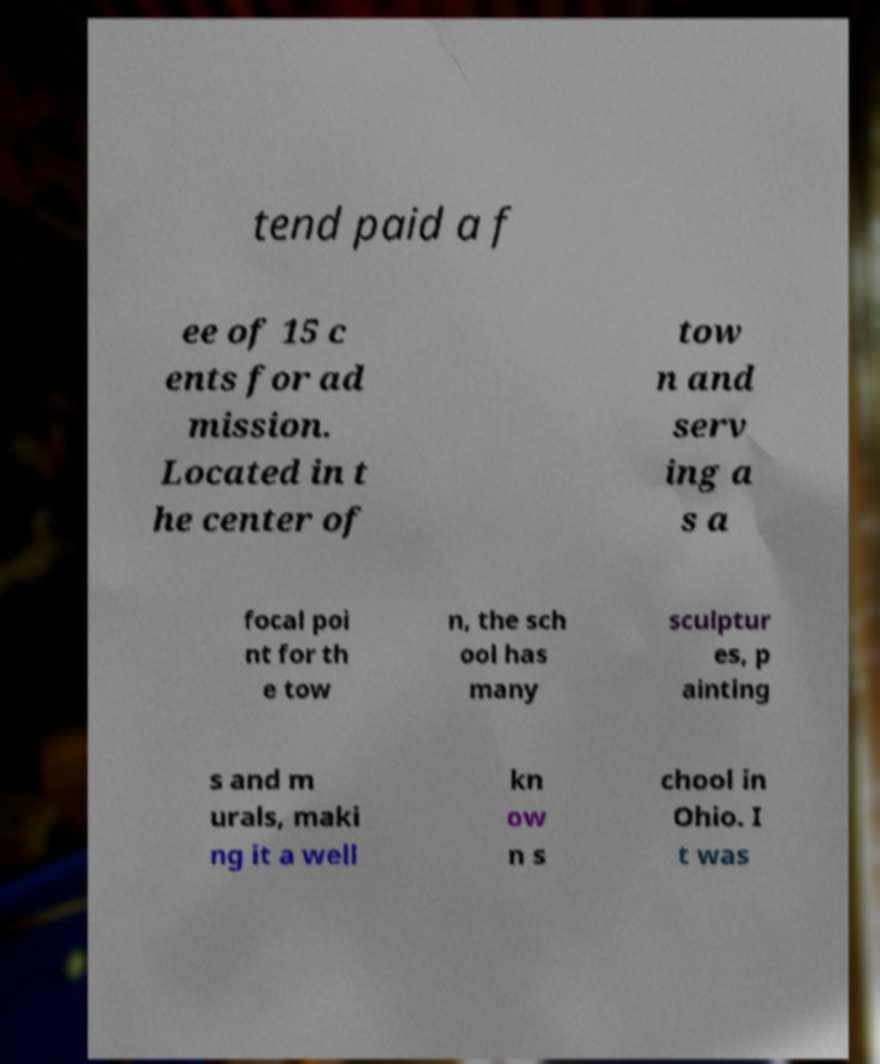There's text embedded in this image that I need extracted. Can you transcribe it verbatim? tend paid a f ee of 15 c ents for ad mission. Located in t he center of tow n and serv ing a s a focal poi nt for th e tow n, the sch ool has many sculptur es, p ainting s and m urals, maki ng it a well kn ow n s chool in Ohio. I t was 